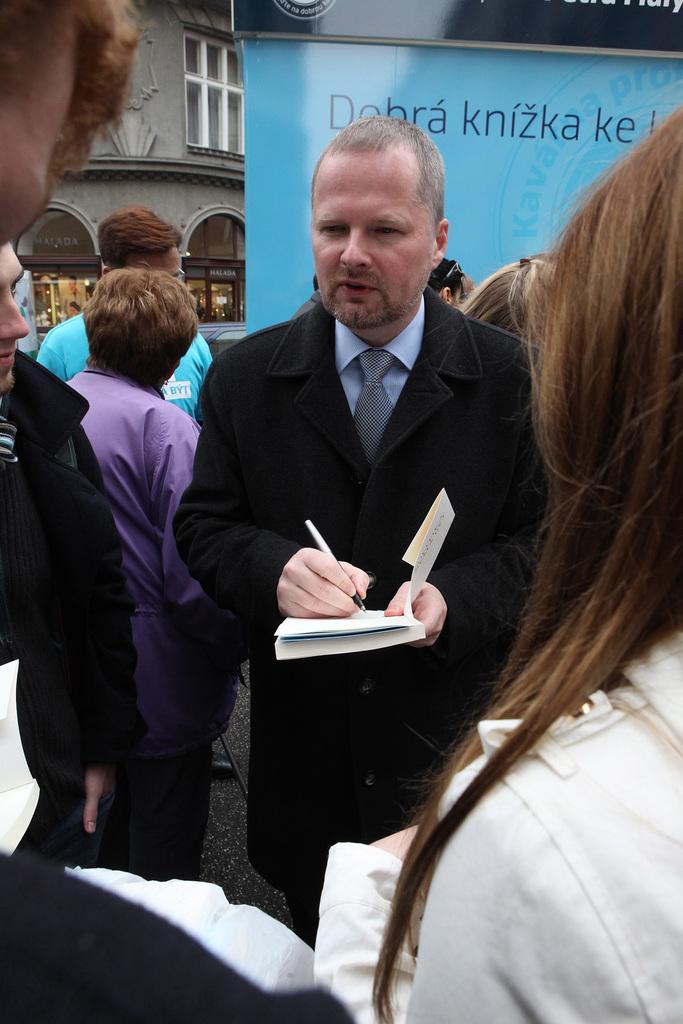How would you summarize this image in a sentence or two? In this image we can see a group of people standing on the ground. One person is holding a book and a pen in his hands. In the background, we can see a car, building with windows and some lights. In the right side of the image we can see a banner with some text. 